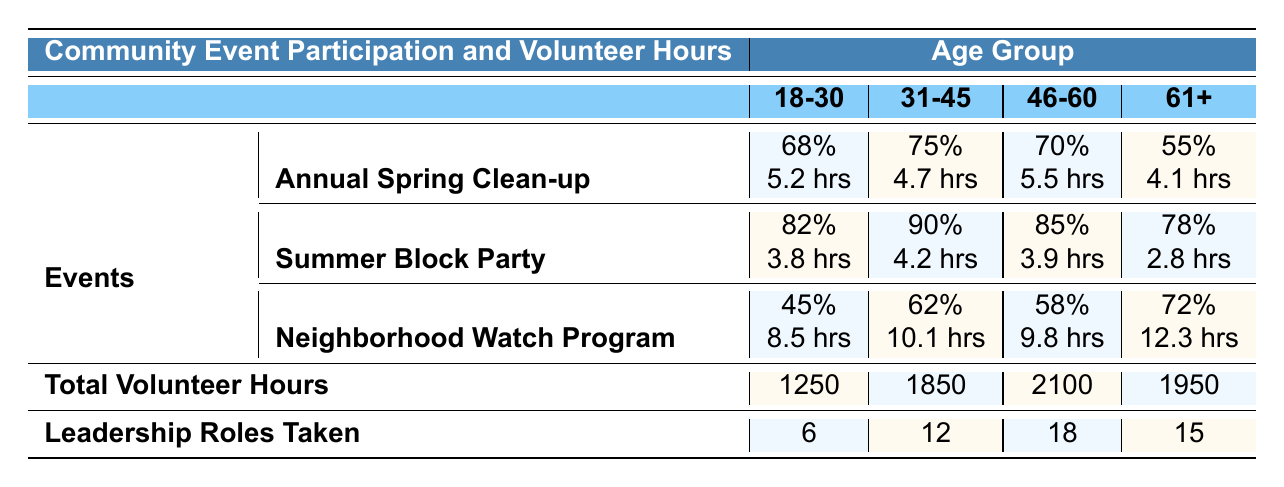What is the participation rate for the "Summer Block Party" in the 31-45 age group? The participation rate for the "Summer Block Party" in the 31-45 age group is indicated in the table under that specific event and age group, which shows it is 90%.
Answer: 90% Which age group has the highest total volunteer hours? By looking at the total volunteer hours listed for each age group, the 46-60 age group has the highest total at 2100 hours compared to the others.
Answer: 46-60 How many leadership roles were taken by participants aged 18-30? The number of leadership roles taken by participants aged 18-30 is provided in the table under the corresponding age group, which shows it is 6.
Answer: 6 What is the average volunteer hours for the "Neighborhood Watch Program" in the 61+ age group? The average volunteer hours for the "Neighborhood Watch Program" in the 61+ age group is listed in the table under that event and age group, which shows it is 12.3 hours.
Answer: 12.3 hours Is the participation rate for the "Annual Spring Clean-up" among the 18-30 age group lower than that of the 61+ age group? The participation rate for the "Annual Spring Clean-up" for the 18-30 age group is 68%, while for the 61+ age group it is 55%. Since 68% is higher than 55%, the statement is false.
Answer: No What is the difference in total volunteer hours between the 31-45 and 61+ age groups? The total volunteer hours for the 31-45 age group is 1850 and for the 61+ age group is 1950. To find the difference, subtract 1850 from 1950, which equals 100.
Answer: 100 hours Which age group has the highest participation rate for the "Neighborhood Watch Program"? The participation rates for the "Neighborhood Watch Program" show that the 61+ age group has the highest at 72%, compared to other age groups.
Answer: 61+ If you combine the volunteer hours from the 18-30 and 31-45 age groups, what is the total? The total volunteer hours for the 18-30 age group is 1250 and for the 31-45 age group is 1850. Adding these two gives 1250 + 1850 = 3100.
Answer: 3100 hours How many leadership roles were taken by participants in the 46-60 age group compared to those in the 18-30 age group? The leadership roles taken by the 46-60 age group is 18 and for the 18-30 age group, it is 6. Thus, 18 is more than 6. The difference is 18 - 6 = 12.
Answer: 12 more Which event has the highest average volunteer hours in the 31-45 age group? The average volunteer hours for each event in the 31-45 age group are: "Annual Spring Clean-up" is 4.7 hours, "Summer Block Party" is 4.2 hours, and "Neighborhood Watch Program" is 10.1 hours. The highest is 10.1 hours for the "Neighborhood Watch Program".
Answer: Neighborhood Watch Program 